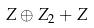<formula> <loc_0><loc_0><loc_500><loc_500>Z \oplus Z _ { 2 } + Z</formula> 